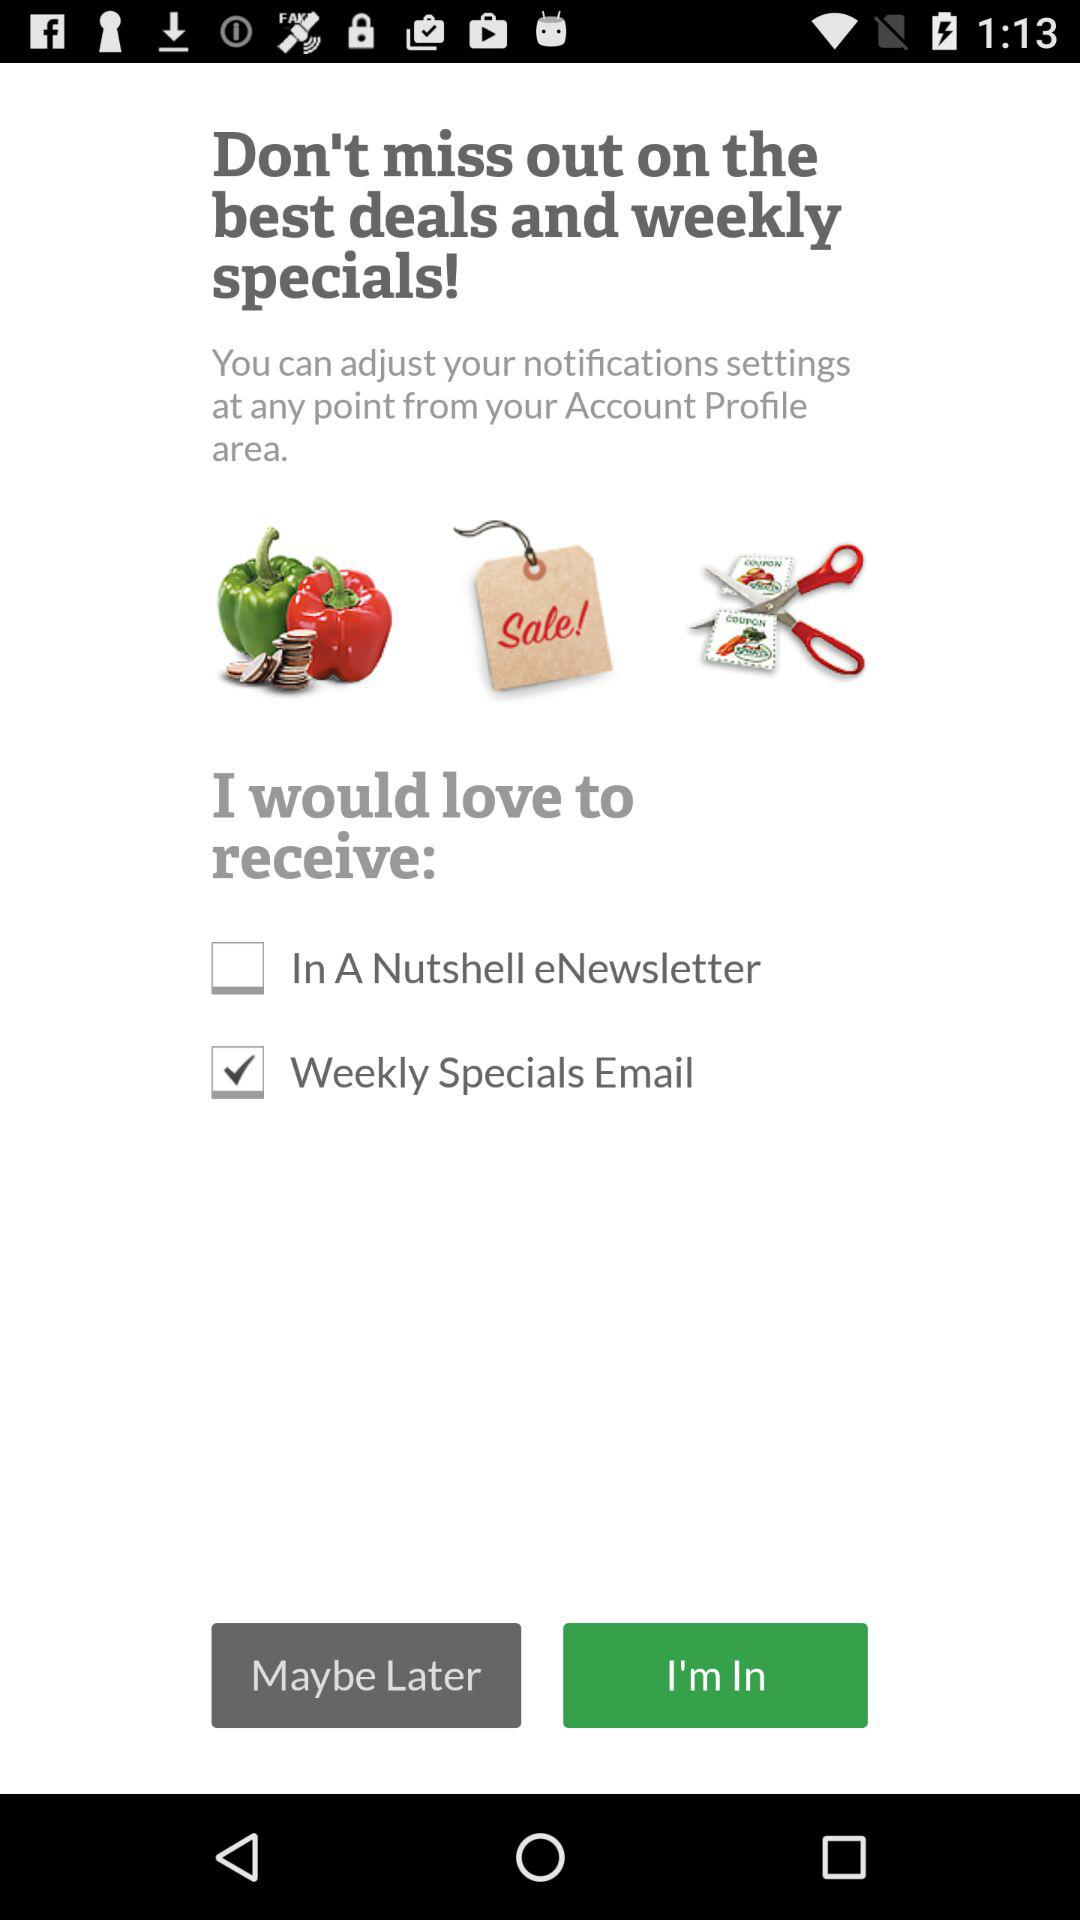How many items have a checkbox on them?
Answer the question using a single word or phrase. 2 